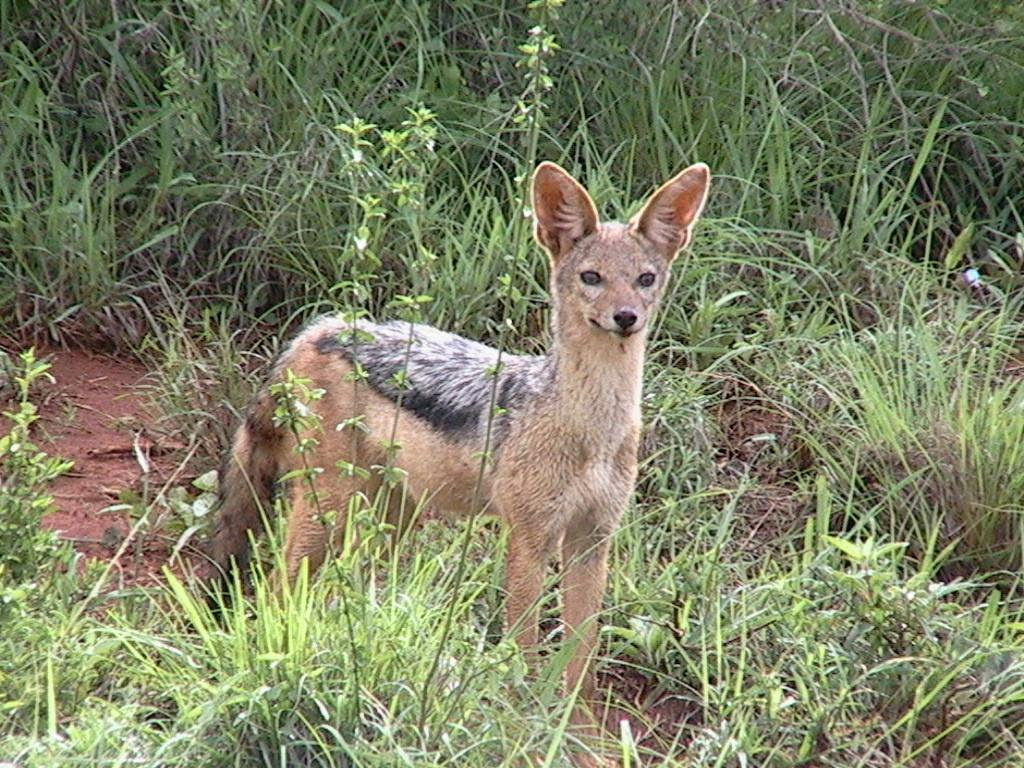What type of living creature is in the picture? There is an animal in the picture. What is the animal doing in the image? The animal is standing on a surface. What can be seen in the area surrounding the animal? The area around the animal is full of grass plants. What type of twig is the animal holding in the image? There is no twig present in the image. What is the animal protesting about in the image? There is no protest or any indication of protest in the image. 